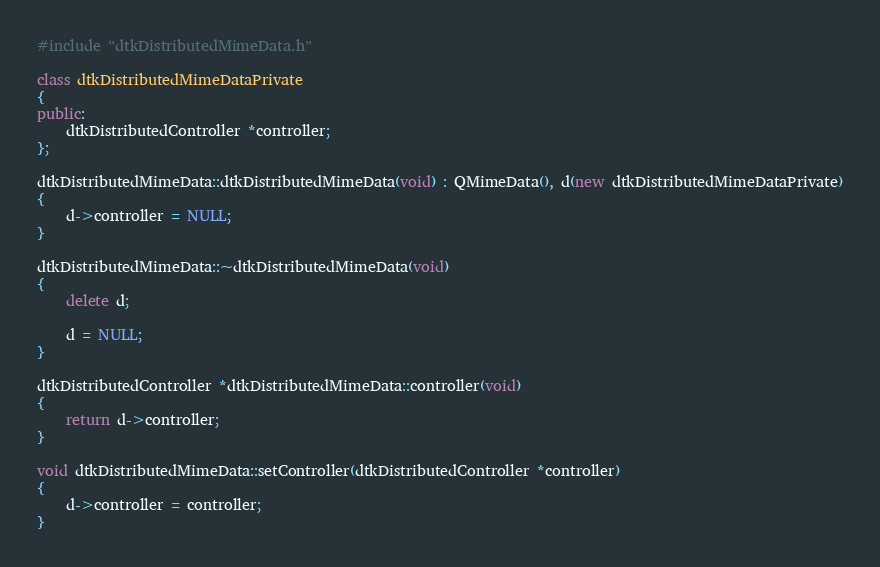Convert code to text. <code><loc_0><loc_0><loc_500><loc_500><_C++_>#include "dtkDistributedMimeData.h"

class dtkDistributedMimeDataPrivate
{
public:
    dtkDistributedController *controller;
};

dtkDistributedMimeData::dtkDistributedMimeData(void) : QMimeData(), d(new dtkDistributedMimeDataPrivate)
{
    d->controller = NULL;
}

dtkDistributedMimeData::~dtkDistributedMimeData(void)
{
    delete d;

    d = NULL;
}

dtkDistributedController *dtkDistributedMimeData::controller(void)
{
    return d->controller;
}

void dtkDistributedMimeData::setController(dtkDistributedController *controller)
{
    d->controller = controller;
}
</code> 